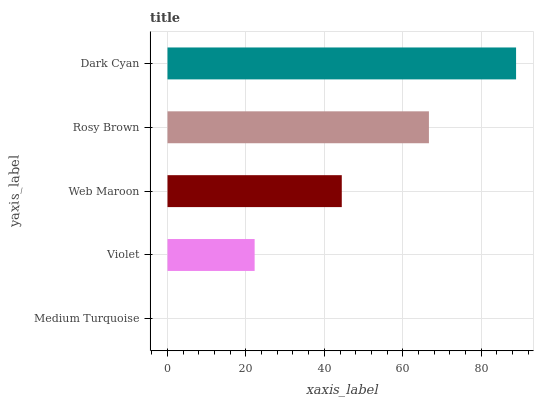Is Medium Turquoise the minimum?
Answer yes or no. Yes. Is Dark Cyan the maximum?
Answer yes or no. Yes. Is Violet the minimum?
Answer yes or no. No. Is Violet the maximum?
Answer yes or no. No. Is Violet greater than Medium Turquoise?
Answer yes or no. Yes. Is Medium Turquoise less than Violet?
Answer yes or no. Yes. Is Medium Turquoise greater than Violet?
Answer yes or no. No. Is Violet less than Medium Turquoise?
Answer yes or no. No. Is Web Maroon the high median?
Answer yes or no. Yes. Is Web Maroon the low median?
Answer yes or no. Yes. Is Dark Cyan the high median?
Answer yes or no. No. Is Violet the low median?
Answer yes or no. No. 